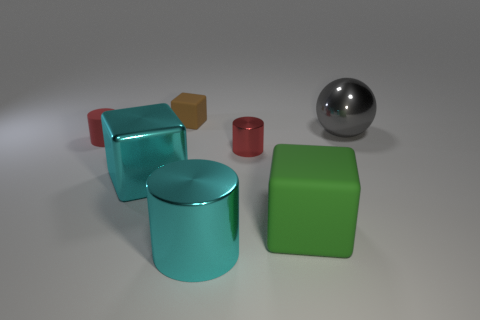Subtract all large metal cylinders. How many cylinders are left? 2 Subtract 1 blocks. How many blocks are left? 2 Subtract all purple cubes. How many red cylinders are left? 2 Add 3 large purple metal balls. How many objects exist? 10 Subtract all gray cylinders. Subtract all gray balls. How many cylinders are left? 3 Subtract all balls. How many objects are left? 6 Subtract all large shiny cylinders. Subtract all large shiny cylinders. How many objects are left? 5 Add 2 cyan things. How many cyan things are left? 4 Add 7 large rubber cubes. How many large rubber cubes exist? 8 Subtract 0 green balls. How many objects are left? 7 